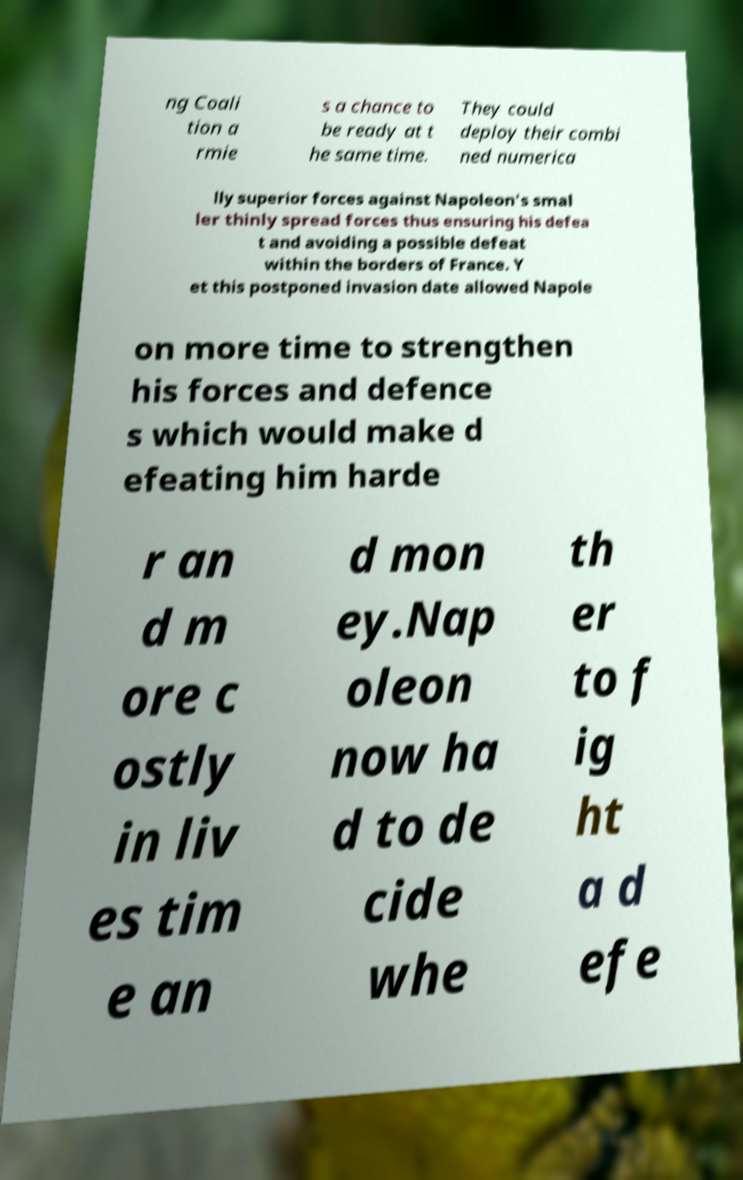What messages or text are displayed in this image? I need them in a readable, typed format. ng Coali tion a rmie s a chance to be ready at t he same time. They could deploy their combi ned numerica lly superior forces against Napoleon's smal ler thinly spread forces thus ensuring his defea t and avoiding a possible defeat within the borders of France. Y et this postponed invasion date allowed Napole on more time to strengthen his forces and defence s which would make d efeating him harde r an d m ore c ostly in liv es tim e an d mon ey.Nap oleon now ha d to de cide whe th er to f ig ht a d efe 